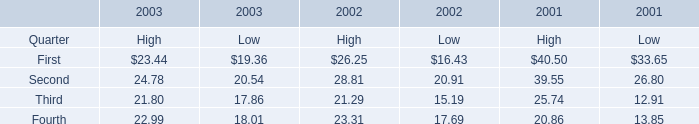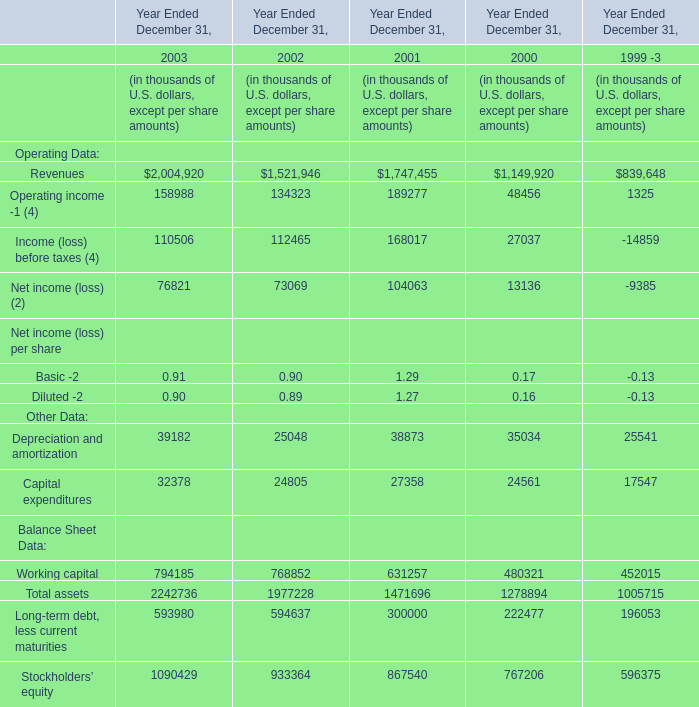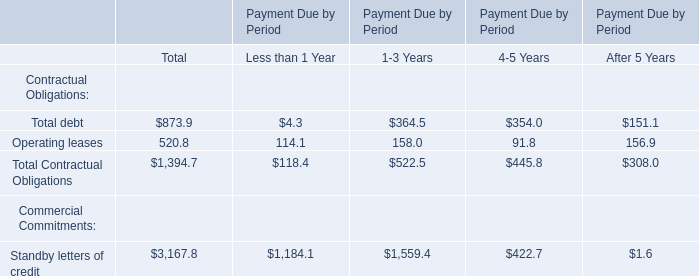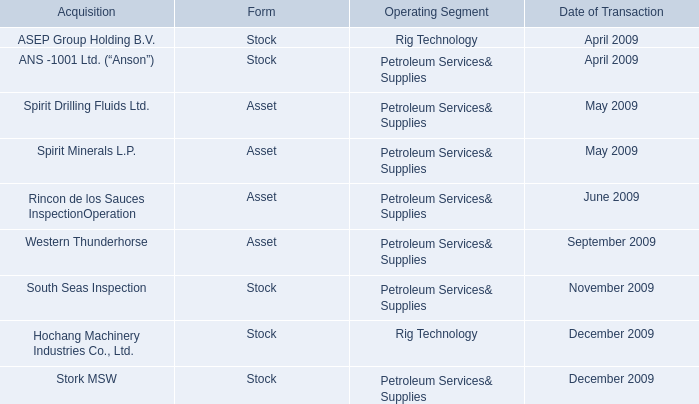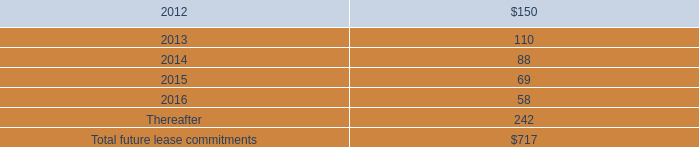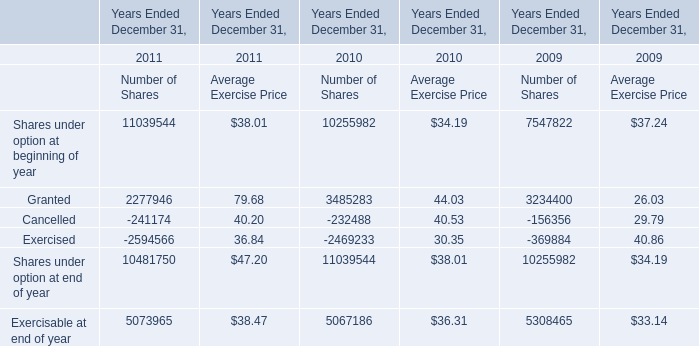Which year is Operating income -1 (4) the most? 
Answer: 2001. 